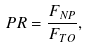<formula> <loc_0><loc_0><loc_500><loc_500>P R = \frac { F _ { N P } } { F _ { T O } } ,</formula> 